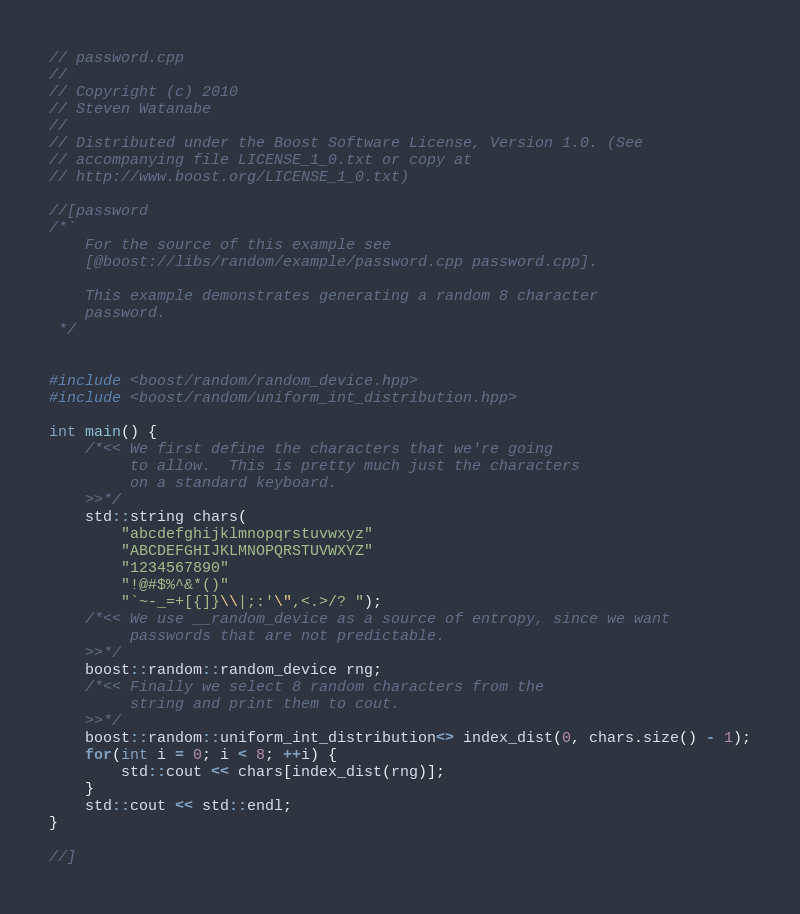<code> <loc_0><loc_0><loc_500><loc_500><_C++_>// password.cpp
//
// Copyright (c) 2010
// Steven Watanabe
//
// Distributed under the Boost Software License, Version 1.0. (See
// accompanying file LICENSE_1_0.txt or copy at
// http://www.boost.org/LICENSE_1_0.txt)

//[password
/*`
    For the source of this example see
    [@boost://libs/random/example/password.cpp password.cpp].

    This example demonstrates generating a random 8 character
    password.
 */


#include <boost/random/random_device.hpp>
#include <boost/random/uniform_int_distribution.hpp>

int main() {
    /*<< We first define the characters that we're going
         to allow.  This is pretty much just the characters
         on a standard keyboard.
    >>*/
    std::string chars(
        "abcdefghijklmnopqrstuvwxyz"
        "ABCDEFGHIJKLMNOPQRSTUVWXYZ"
        "1234567890"
        "!@#$%^&*()"
        "`~-_=+[{]}\\|;:'\",<.>/? ");
    /*<< We use __random_device as a source of entropy, since we want
         passwords that are not predictable.
    >>*/
    boost::random::random_device rng;
    /*<< Finally we select 8 random characters from the
         string and print them to cout.
    >>*/
    boost::random::uniform_int_distribution<> index_dist(0, chars.size() - 1);
    for(int i = 0; i < 8; ++i) {
        std::cout << chars[index_dist(rng)];
    }
    std::cout << std::endl;
}

//]
</code> 